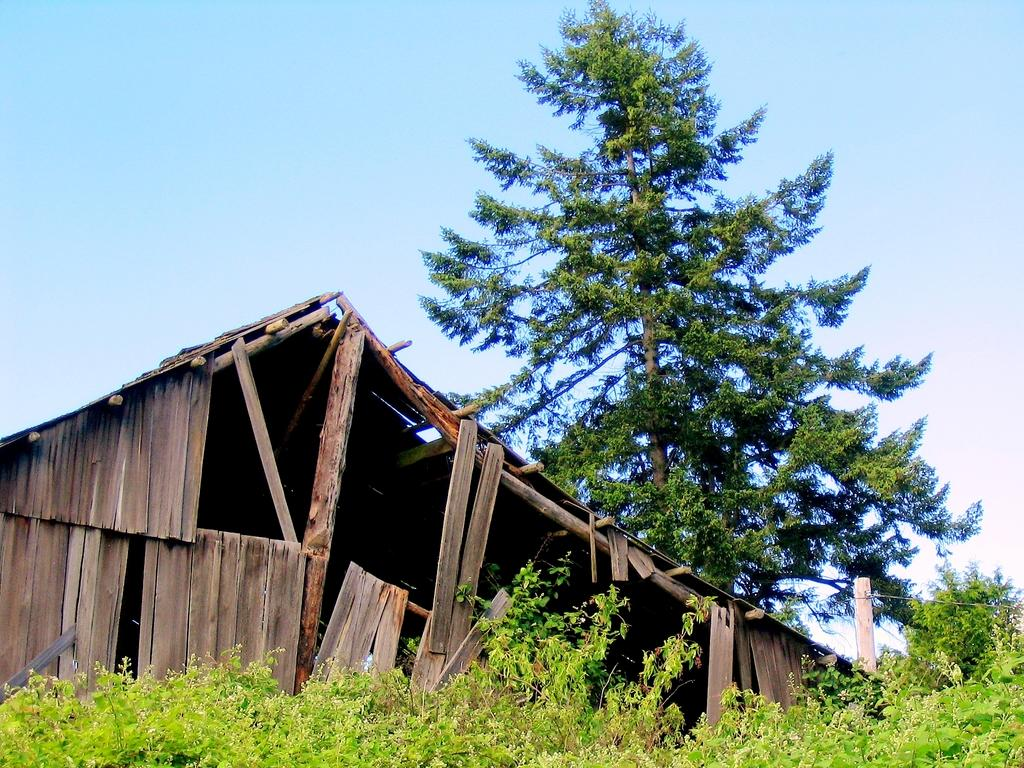What is the main subject of the image? There is a collapsed wooden building in the image. What else can be seen in the image besides the building? There are plants visible in the image. What is visible in the background of the image? There are trees and the sky visible in the background of the image. What type of wine is being served at the railway station in the image? There is no wine or railway station present in the image; it features a collapsed wooden building and plants. What scientific theory is being discussed by the people in the image? There are no people or discussions about scientific theories present in the image. 